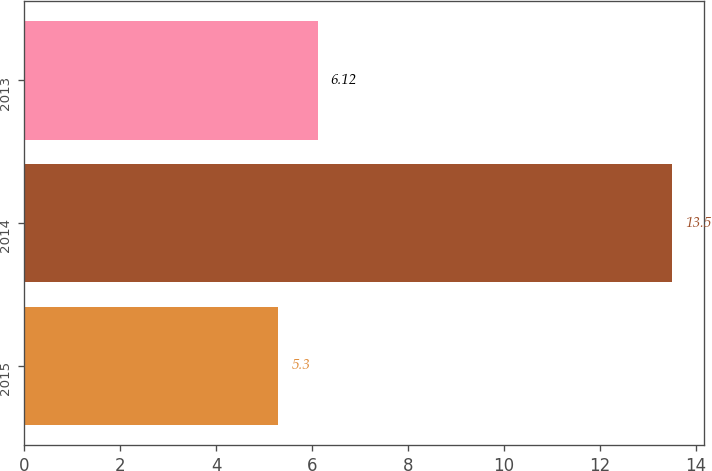<chart> <loc_0><loc_0><loc_500><loc_500><bar_chart><fcel>2015<fcel>2014<fcel>2013<nl><fcel>5.3<fcel>13.5<fcel>6.12<nl></chart> 